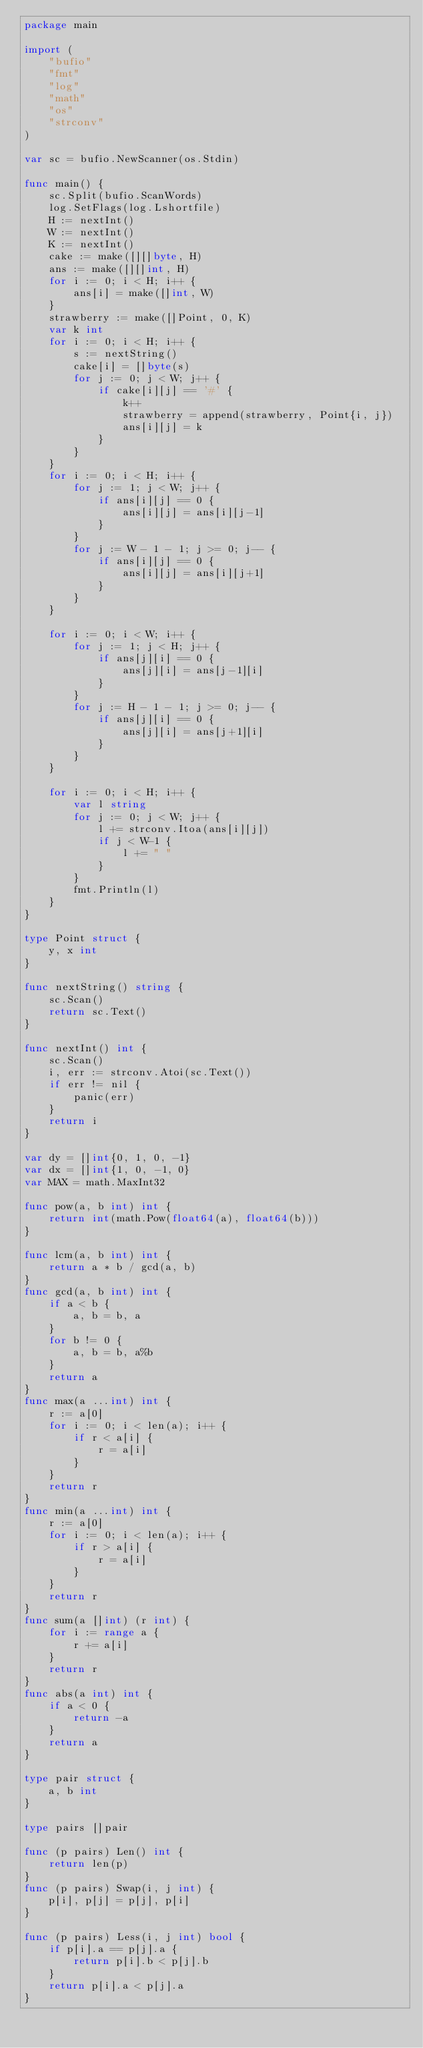Convert code to text. <code><loc_0><loc_0><loc_500><loc_500><_Go_>package main

import (
	"bufio"
	"fmt"
	"log"
	"math"
	"os"
	"strconv"
)

var sc = bufio.NewScanner(os.Stdin)

func main() {
	sc.Split(bufio.ScanWords)
	log.SetFlags(log.Lshortfile)
	H := nextInt()
	W := nextInt()
	K := nextInt()
	cake := make([][]byte, H)
	ans := make([][]int, H)
	for i := 0; i < H; i++ {
		ans[i] = make([]int, W)
	}
	strawberry := make([]Point, 0, K)
	var k int
	for i := 0; i < H; i++ {
		s := nextString()
		cake[i] = []byte(s)
		for j := 0; j < W; j++ {
			if cake[i][j] == '#' {
				k++
				strawberry = append(strawberry, Point{i, j})
				ans[i][j] = k
			}
		}
	}
	for i := 0; i < H; i++ {
		for j := 1; j < W; j++ {
			if ans[i][j] == 0 {
				ans[i][j] = ans[i][j-1]
			}
		}
		for j := W - 1 - 1; j >= 0; j-- {
			if ans[i][j] == 0 {
				ans[i][j] = ans[i][j+1]
			}
		}
	}

	for i := 0; i < W; i++ {
		for j := 1; j < H; j++ {
			if ans[j][i] == 0 {
				ans[j][i] = ans[j-1][i]
			}
		}
		for j := H - 1 - 1; j >= 0; j-- {
			if ans[j][i] == 0 {
				ans[j][i] = ans[j+1][i]
			}
		}
	}

	for i := 0; i < H; i++ {
		var l string
		for j := 0; j < W; j++ {
			l += strconv.Itoa(ans[i][j])
			if j < W-1 {
				l += " "
			}
		}
		fmt.Println(l)
	}
}

type Point struct {
	y, x int
}

func nextString() string {
	sc.Scan()
	return sc.Text()
}

func nextInt() int {
	sc.Scan()
	i, err := strconv.Atoi(sc.Text())
	if err != nil {
		panic(err)
	}
	return i
}

var dy = []int{0, 1, 0, -1}
var dx = []int{1, 0, -1, 0}
var MAX = math.MaxInt32

func pow(a, b int) int {
	return int(math.Pow(float64(a), float64(b)))
}

func lcm(a, b int) int {
	return a * b / gcd(a, b)
}
func gcd(a, b int) int {
	if a < b {
		a, b = b, a
	}
	for b != 0 {
		a, b = b, a%b
	}
	return a
}
func max(a ...int) int {
	r := a[0]
	for i := 0; i < len(a); i++ {
		if r < a[i] {
			r = a[i]
		}
	}
	return r
}
func min(a ...int) int {
	r := a[0]
	for i := 0; i < len(a); i++ {
		if r > a[i] {
			r = a[i]
		}
	}
	return r
}
func sum(a []int) (r int) {
	for i := range a {
		r += a[i]
	}
	return r
}
func abs(a int) int {
	if a < 0 {
		return -a
	}
	return a
}

type pair struct {
	a, b int
}

type pairs []pair

func (p pairs) Len() int {
	return len(p)
}
func (p pairs) Swap(i, j int) {
	p[i], p[j] = p[j], p[i]
}

func (p pairs) Less(i, j int) bool {
	if p[i].a == p[j].a {
		return p[i].b < p[j].b
	}
	return p[i].a < p[j].a
}
</code> 